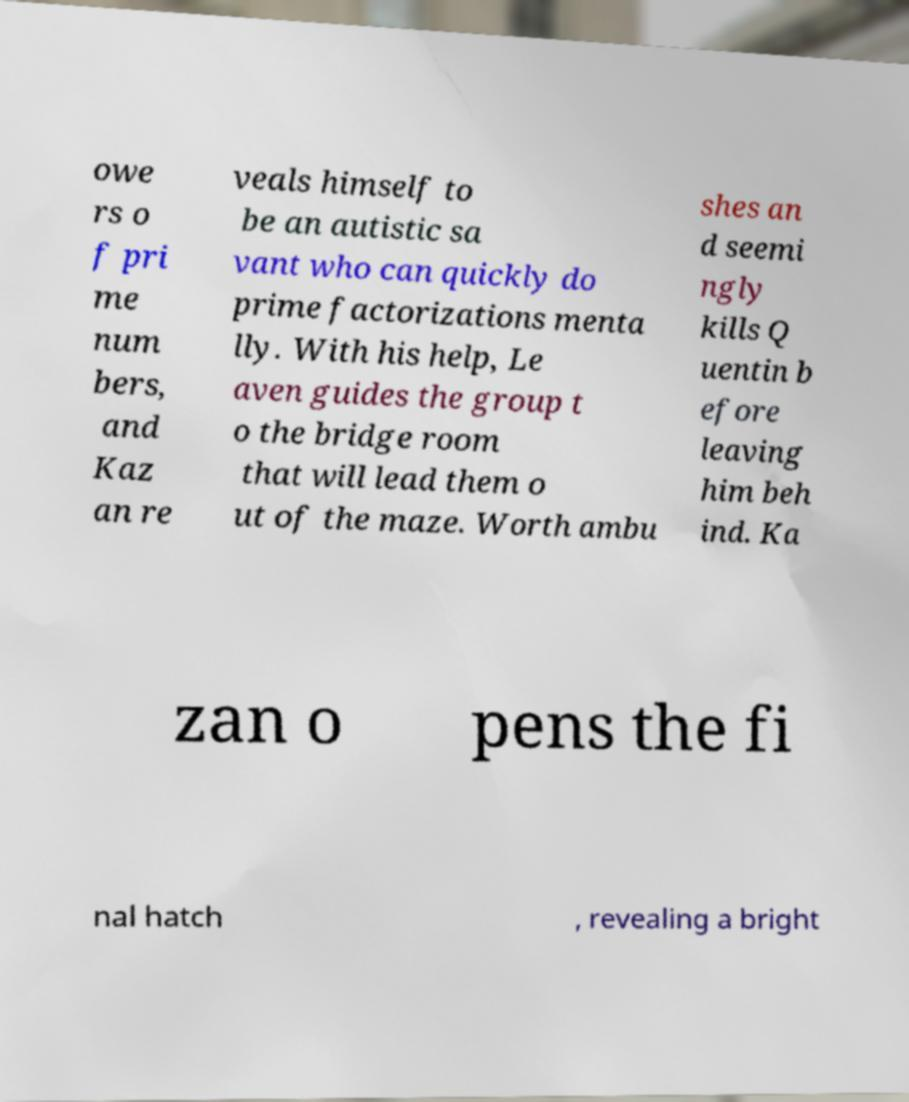Can you read and provide the text displayed in the image?This photo seems to have some interesting text. Can you extract and type it out for me? owe rs o f pri me num bers, and Kaz an re veals himself to be an autistic sa vant who can quickly do prime factorizations menta lly. With his help, Le aven guides the group t o the bridge room that will lead them o ut of the maze. Worth ambu shes an d seemi ngly kills Q uentin b efore leaving him beh ind. Ka zan o pens the fi nal hatch , revealing a bright 